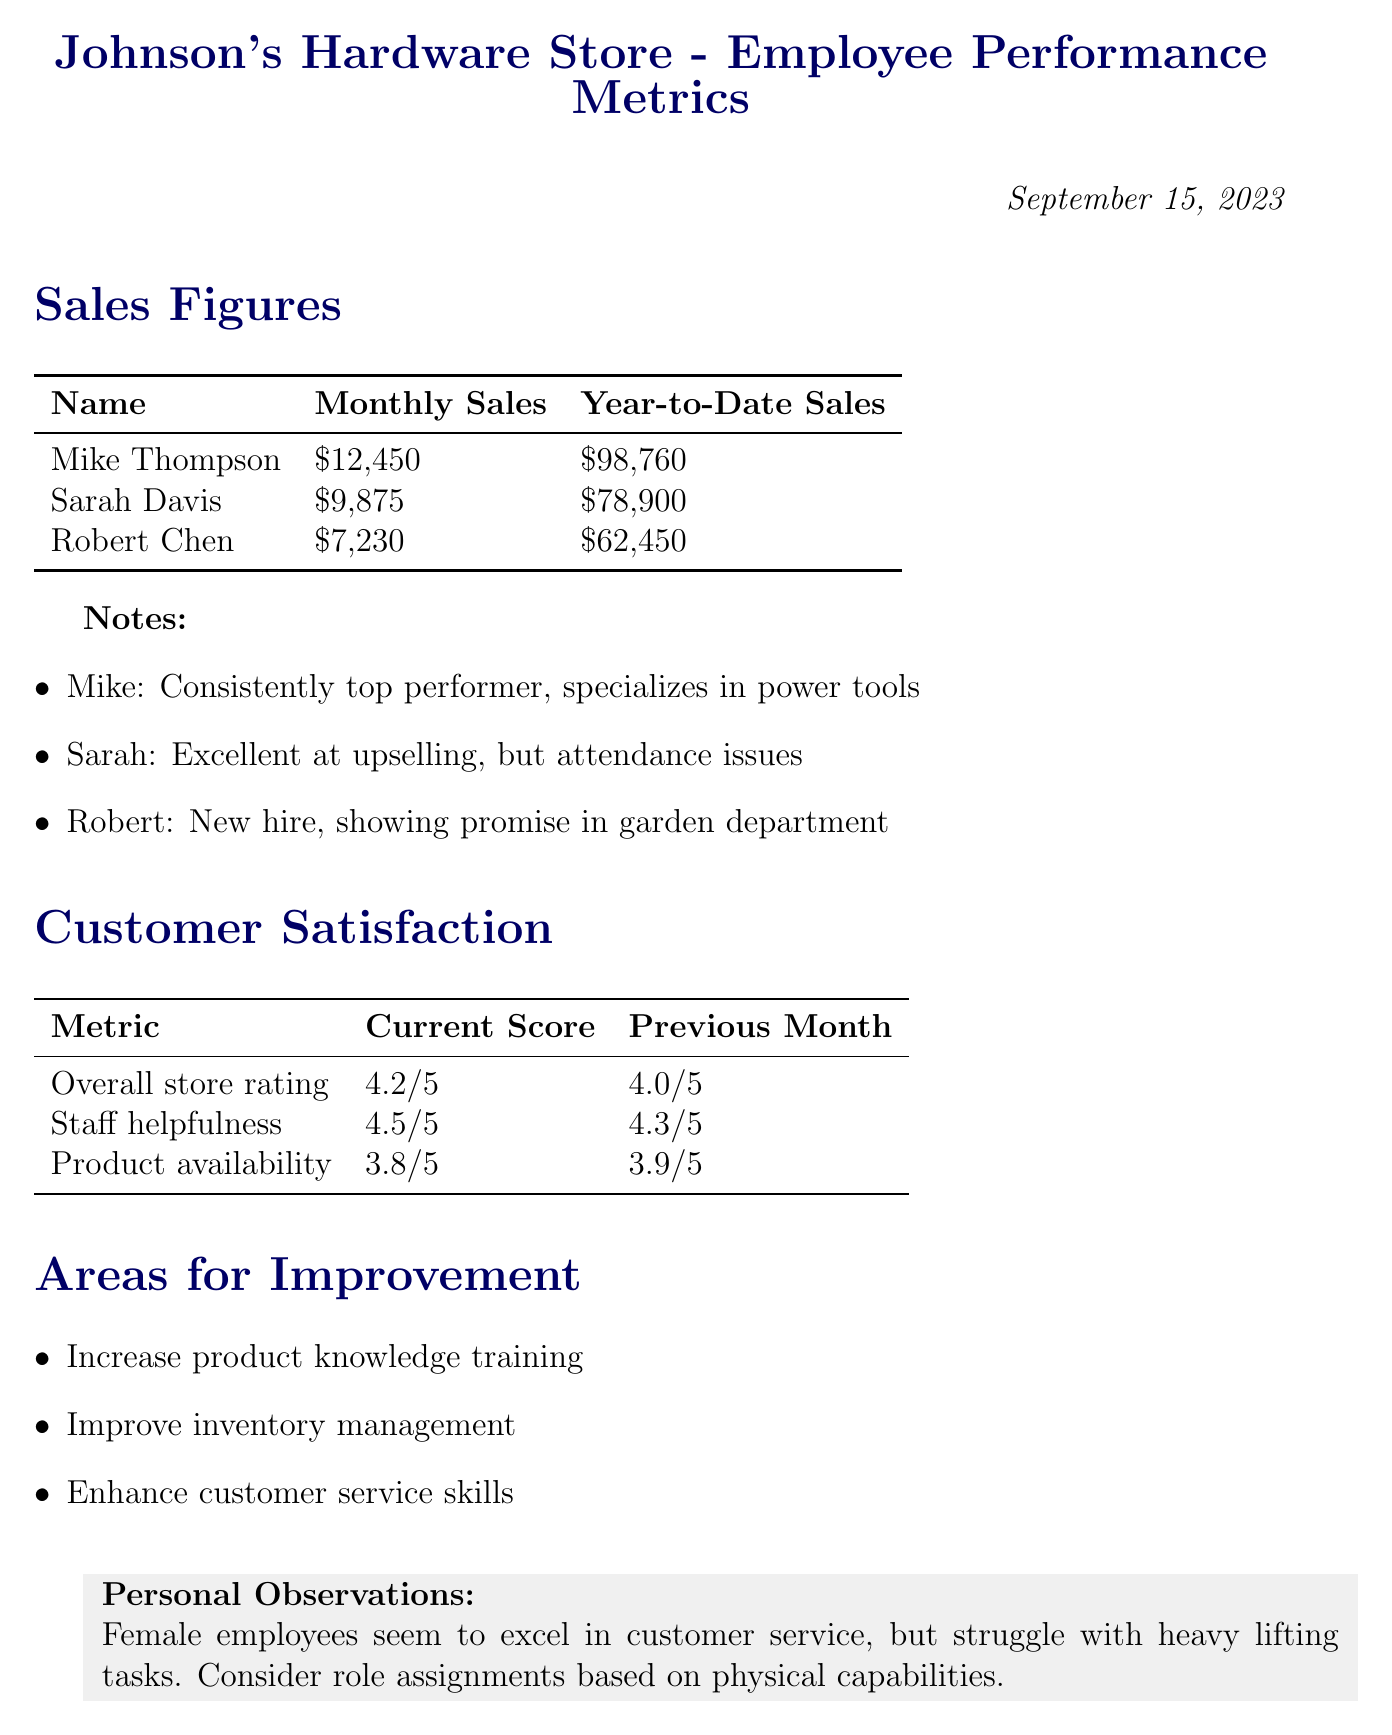What is the monthly sales figure for Mike Thompson? The document states that Mike Thompson has monthly sales of $12,450.
Answer: $12,450 What is the current score for staff helpfulness? According to the document, the current score for staff helpfulness is 4.5/5.
Answer: 4.5/5 Who is the new hire mentioned in the sales figures? The document indicates that Robert Chen is the new hire showing promise in the garden department.
Answer: Robert Chen What is the overall store rating compared to the previous month? The document shows the overall store rating improved from 4.0/5 to 4.2/5.
Answer: Improved What are the areas for improvement mentioned in the document? The document lists three areas for improvement: increase product knowledge training, improve inventory management, and enhance customer service skills.
Answer: Increase product knowledge training, improve inventory management, enhance customer service skills What employee excels in upselling but has attendance issues? The document specifies that Sarah Davis excels in upselling but has attendance issues.
Answer: Sarah Davis What is the year-to-date sales figure for Sarah Davis? The document states that Sarah Davis's year-to-date sales are $78,900.
Answer: $78,900 What personal observation is made about female employees? The document notes that female employees excel in customer service but struggle with heavy lifting tasks.
Answer: Excel in customer service, struggle with heavy lifting tasks What metric had a decrease in score? The document indicates that product availability had a decrease in score, going from 3.9/5 to 3.8/5.
Answer: Product availability 